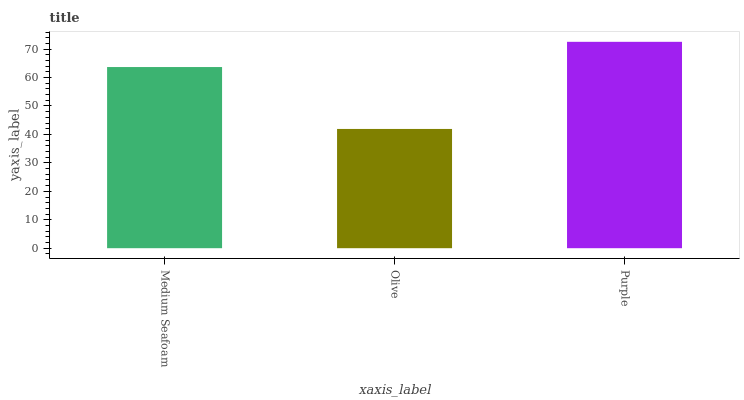Is Olive the minimum?
Answer yes or no. Yes. Is Purple the maximum?
Answer yes or no. Yes. Is Purple the minimum?
Answer yes or no. No. Is Olive the maximum?
Answer yes or no. No. Is Purple greater than Olive?
Answer yes or no. Yes. Is Olive less than Purple?
Answer yes or no. Yes. Is Olive greater than Purple?
Answer yes or no. No. Is Purple less than Olive?
Answer yes or no. No. Is Medium Seafoam the high median?
Answer yes or no. Yes. Is Medium Seafoam the low median?
Answer yes or no. Yes. Is Purple the high median?
Answer yes or no. No. Is Purple the low median?
Answer yes or no. No. 